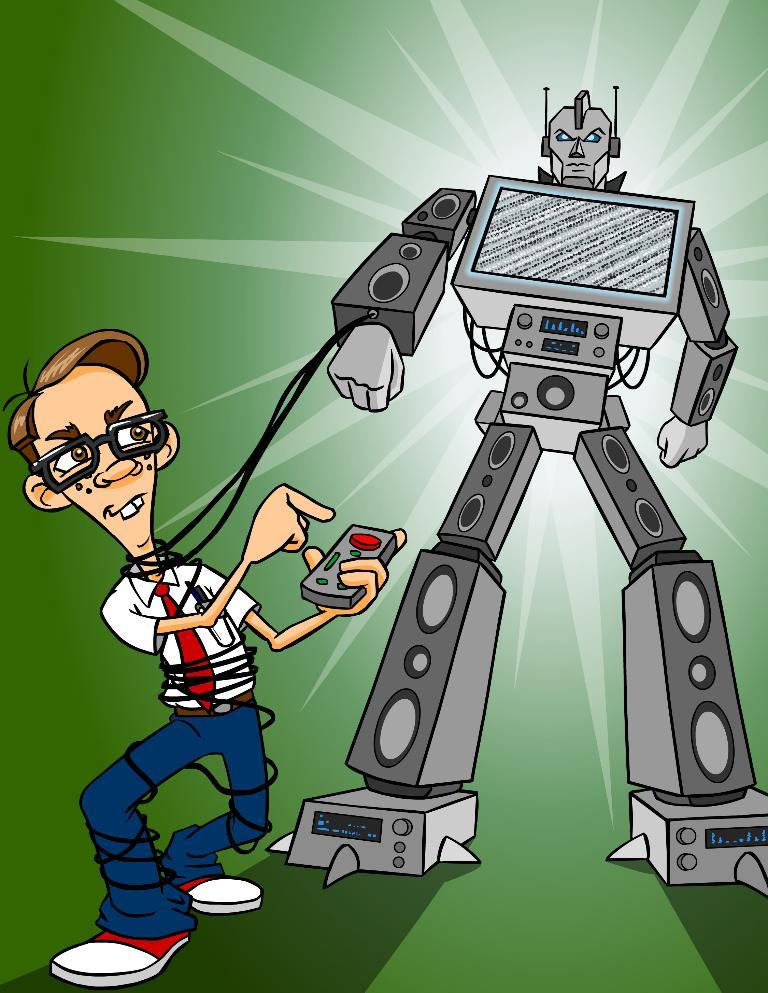What type of character is located on the right side of the image? There is an animated robot on the right side of the image. What type of character is located on the left side of the image? There is an animated image of a boy on the left side of the image. What is the boy holding in the image? The boy is holding a remote in the image. Where is the robot positioned in relation to the boy? The robot is on the right side of the image, while the boy is on the left side. What type of brass instrument is the boy playing in the image? There is no brass instrument present in the image; the boy is holding a remote. 